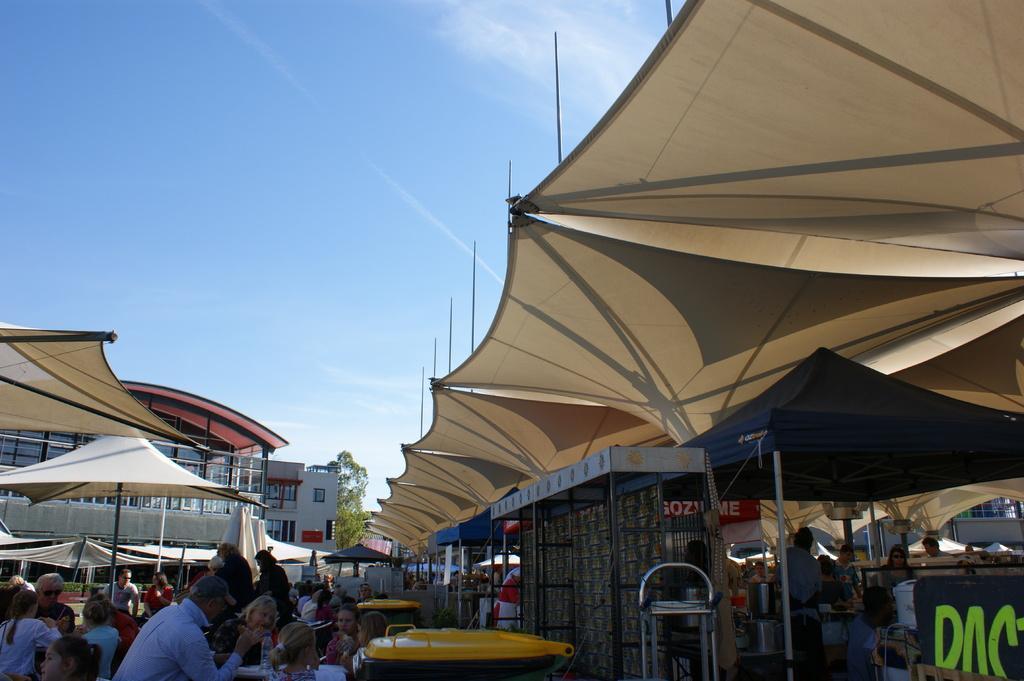Describe this image in one or two sentences. In this image I can see group of people, some are sitting and some are standing and I can see few tents in white color. Background I can see few buildings, trees in green color, few poles and I can also see few stalls and the sky is in blue and white color. 